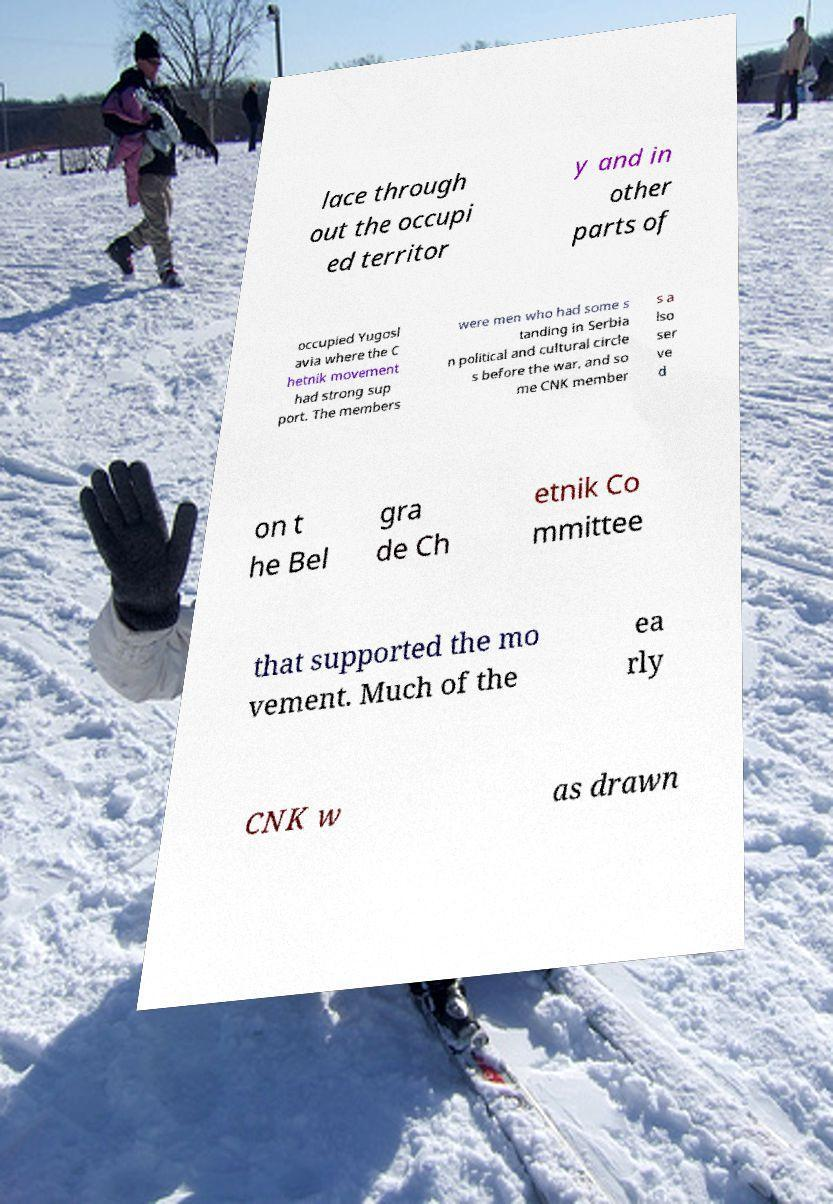For documentation purposes, I need the text within this image transcribed. Could you provide that? lace through out the occupi ed territor y and in other parts of occupied Yugosl avia where the C hetnik movement had strong sup port. The members were men who had some s tanding in Serbia n political and cultural circle s before the war, and so me CNK member s a lso ser ve d on t he Bel gra de Ch etnik Co mmittee that supported the mo vement. Much of the ea rly CNK w as drawn 